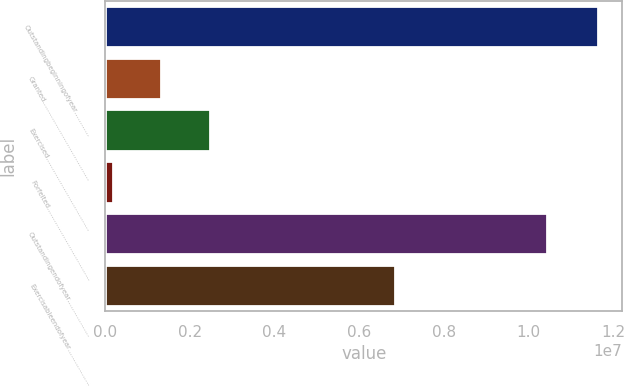Convert chart. <chart><loc_0><loc_0><loc_500><loc_500><bar_chart><fcel>Outstandingbeginningofyear…………<fcel>Granted…………………………………<fcel>Exercised………………………………<fcel>Forfeited………………………………<fcel>Outstandingendofyear………………<fcel>Exercisableendofyear………………<nl><fcel>1.16416e+07<fcel>1.32725e+06<fcel>2.47328e+06<fcel>181212<fcel>1.04447e+07<fcel>6.85384e+06<nl></chart> 